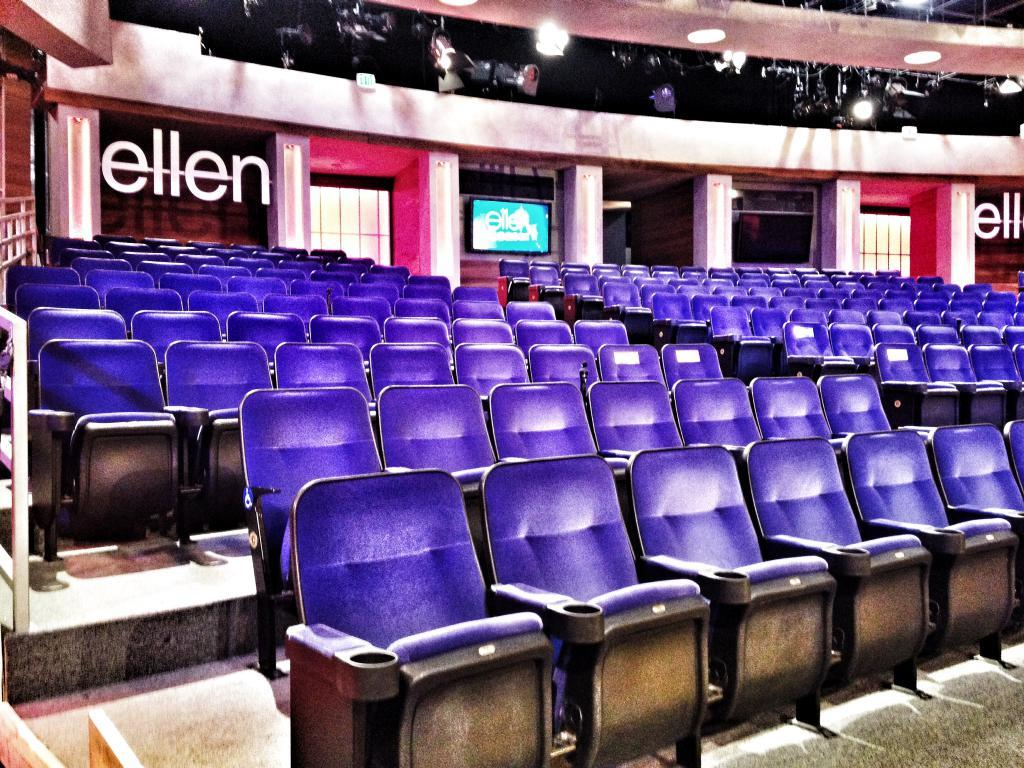What type of furniture is visible in the image? There are empty chairs in the image. What color are the chairs? The chairs are violet in color. What can be seen in the background of the image? There is a television and lights in the background of the image. Are there any other objects present in the background of the image? Yes, there are other objects present in the background of the image. What type of produce is being sold in the image? There is no produce present in the image; it features empty violet chairs and objects in the background. Is there a scarf draped over one of the chairs in the image? No, there is no scarf present in the image. 